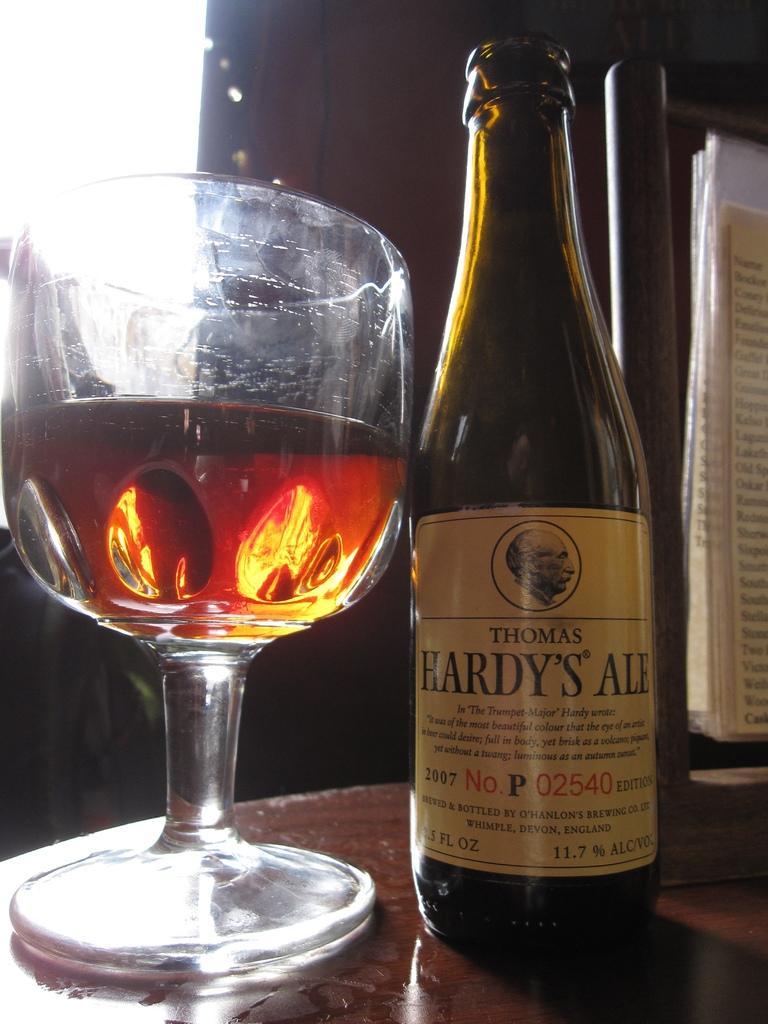Could you give a brief overview of what you see in this image? In this image in the foreground there is one bottle, and glass and in the glass there is some drink. And at the bottom there is a table, and on the right side of the image there are some papers and some object. And in the background there is a window and wall. 